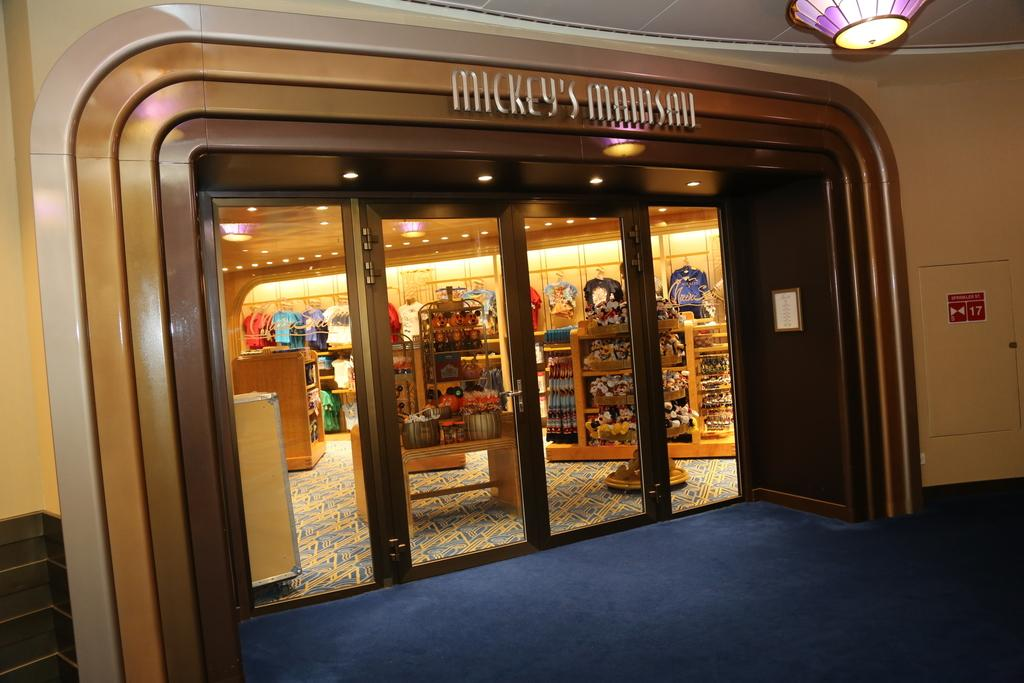<image>
Share a concise interpretation of the image provided. A Mickey's Mainsail store front with glass doors. 